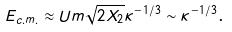<formula> <loc_0><loc_0><loc_500><loc_500>E _ { c . m . } \approx U m \sqrt { 2 X _ { 2 } } \kappa ^ { - 1 / 3 } \sim \kappa ^ { - 1 / 3 } \text {.}</formula> 